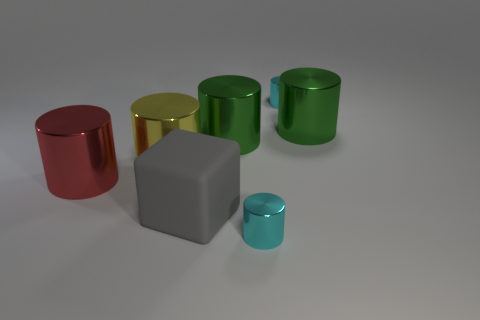Subtract all red shiny cylinders. How many cylinders are left? 5 Subtract all green spheres. How many green cylinders are left? 2 Add 1 blue metallic cubes. How many objects exist? 8 Subtract all yellow cylinders. How many cylinders are left? 5 Subtract all blocks. How many objects are left? 6 Subtract 3 cylinders. How many cylinders are left? 3 Subtract 0 gray cylinders. How many objects are left? 7 Subtract all cyan cylinders. Subtract all red blocks. How many cylinders are left? 4 Subtract all gray things. Subtract all metallic objects. How many objects are left? 0 Add 3 small cyan shiny cylinders. How many small cyan shiny cylinders are left? 5 